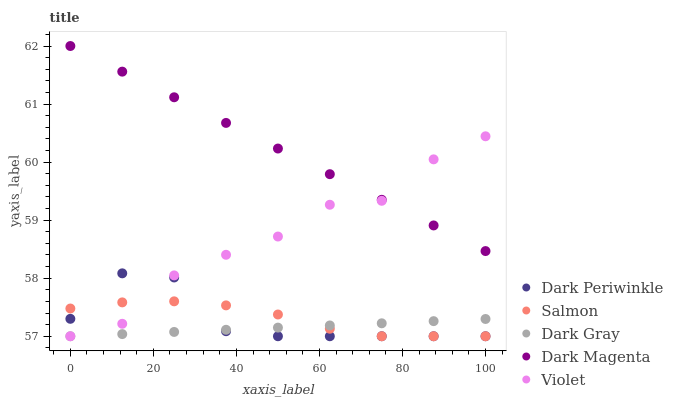Does Dark Gray have the minimum area under the curve?
Answer yes or no. Yes. Does Dark Magenta have the maximum area under the curve?
Answer yes or no. Yes. Does Violet have the minimum area under the curve?
Answer yes or no. No. Does Violet have the maximum area under the curve?
Answer yes or no. No. Is Dark Magenta the smoothest?
Answer yes or no. Yes. Is Violet the roughest?
Answer yes or no. Yes. Is Salmon the smoothest?
Answer yes or no. No. Is Salmon the roughest?
Answer yes or no. No. Does Dark Gray have the lowest value?
Answer yes or no. Yes. Does Dark Magenta have the lowest value?
Answer yes or no. No. Does Dark Magenta have the highest value?
Answer yes or no. Yes. Does Violet have the highest value?
Answer yes or no. No. Is Dark Gray less than Dark Magenta?
Answer yes or no. Yes. Is Dark Magenta greater than Dark Gray?
Answer yes or no. Yes. Does Dark Magenta intersect Violet?
Answer yes or no. Yes. Is Dark Magenta less than Violet?
Answer yes or no. No. Is Dark Magenta greater than Violet?
Answer yes or no. No. Does Dark Gray intersect Dark Magenta?
Answer yes or no. No. 